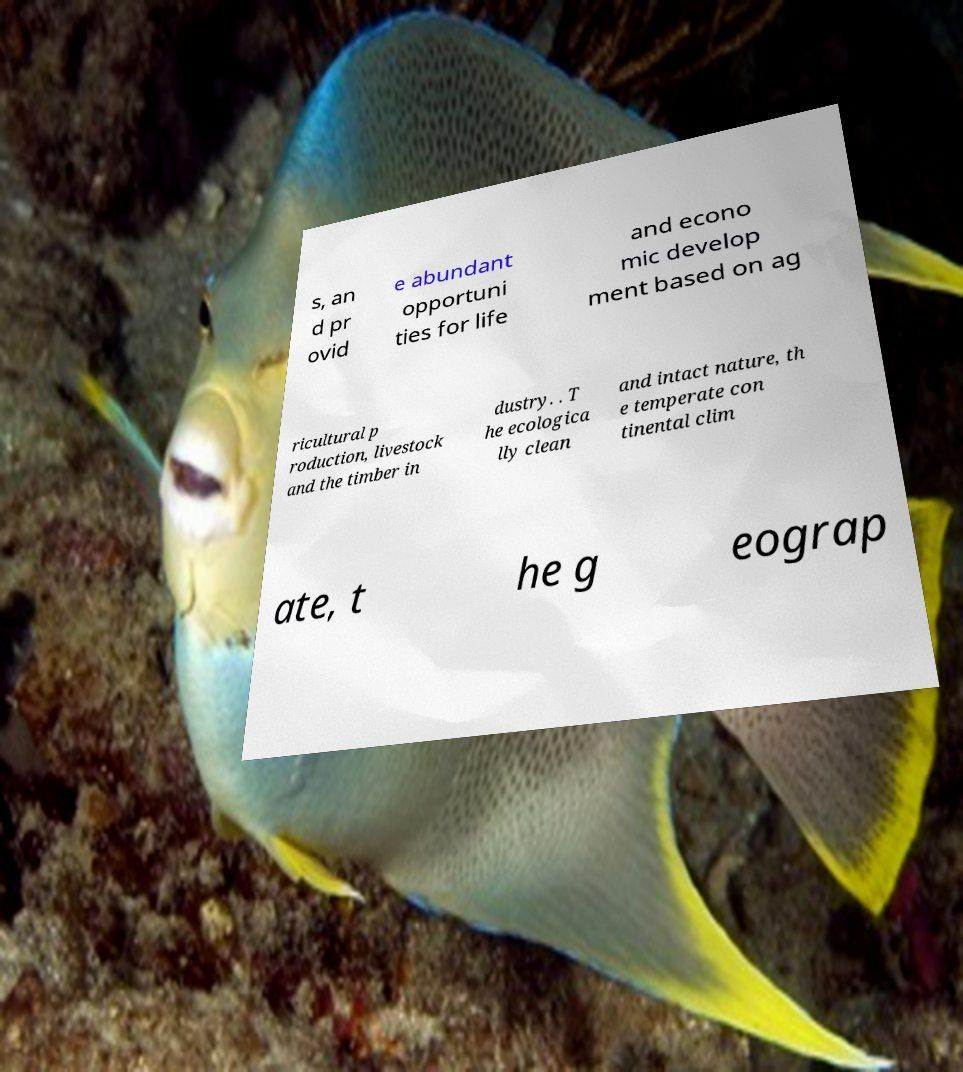There's text embedded in this image that I need extracted. Can you transcribe it verbatim? s, an d pr ovid e abundant opportuni ties for life and econo mic develop ment based on ag ricultural p roduction, livestock and the timber in dustry. . T he ecologica lly clean and intact nature, th e temperate con tinental clim ate, t he g eograp 